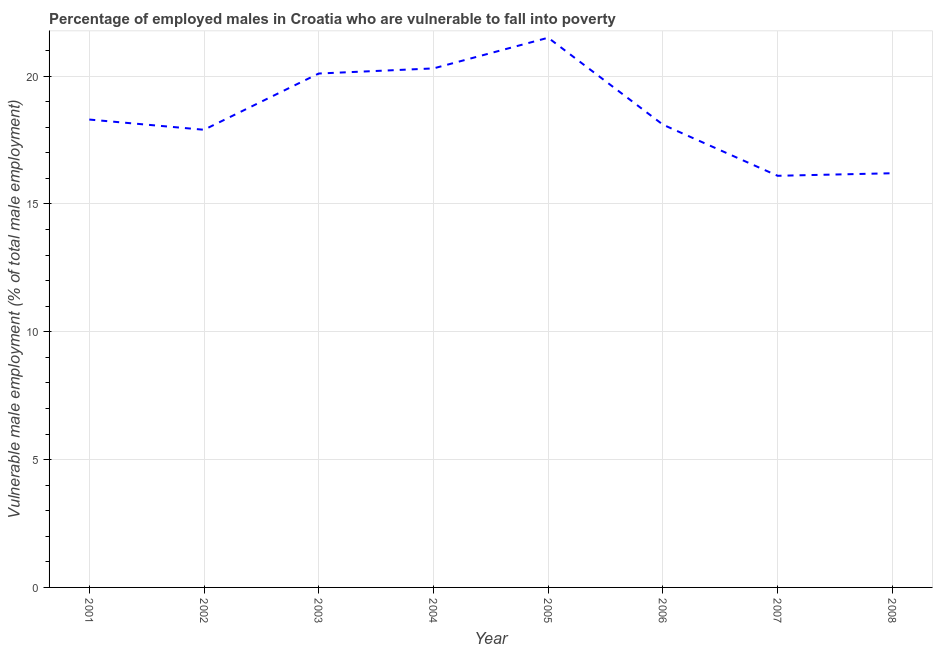What is the percentage of employed males who are vulnerable to fall into poverty in 2005?
Ensure brevity in your answer.  21.5. Across all years, what is the minimum percentage of employed males who are vulnerable to fall into poverty?
Make the answer very short. 16.1. In which year was the percentage of employed males who are vulnerable to fall into poverty maximum?
Make the answer very short. 2005. In which year was the percentage of employed males who are vulnerable to fall into poverty minimum?
Your answer should be very brief. 2007. What is the sum of the percentage of employed males who are vulnerable to fall into poverty?
Ensure brevity in your answer.  148.5. What is the difference between the percentage of employed males who are vulnerable to fall into poverty in 2001 and 2007?
Provide a short and direct response. 2.2. What is the average percentage of employed males who are vulnerable to fall into poverty per year?
Your answer should be very brief. 18.56. What is the median percentage of employed males who are vulnerable to fall into poverty?
Your answer should be compact. 18.2. In how many years, is the percentage of employed males who are vulnerable to fall into poverty greater than 9 %?
Your answer should be compact. 8. What is the ratio of the percentage of employed males who are vulnerable to fall into poverty in 2003 to that in 2007?
Offer a terse response. 1.25. What is the difference between the highest and the second highest percentage of employed males who are vulnerable to fall into poverty?
Keep it short and to the point. 1.2. What is the difference between the highest and the lowest percentage of employed males who are vulnerable to fall into poverty?
Give a very brief answer. 5.4. Does the percentage of employed males who are vulnerable to fall into poverty monotonically increase over the years?
Your answer should be compact. No. How many lines are there?
Offer a very short reply. 1. Are the values on the major ticks of Y-axis written in scientific E-notation?
Your response must be concise. No. Does the graph contain grids?
Offer a terse response. Yes. What is the title of the graph?
Offer a very short reply. Percentage of employed males in Croatia who are vulnerable to fall into poverty. What is the label or title of the X-axis?
Offer a terse response. Year. What is the label or title of the Y-axis?
Keep it short and to the point. Vulnerable male employment (% of total male employment). What is the Vulnerable male employment (% of total male employment) in 2001?
Offer a very short reply. 18.3. What is the Vulnerable male employment (% of total male employment) in 2002?
Your response must be concise. 17.9. What is the Vulnerable male employment (% of total male employment) of 2003?
Provide a short and direct response. 20.1. What is the Vulnerable male employment (% of total male employment) of 2004?
Your answer should be very brief. 20.3. What is the Vulnerable male employment (% of total male employment) in 2006?
Offer a very short reply. 18.1. What is the Vulnerable male employment (% of total male employment) in 2007?
Ensure brevity in your answer.  16.1. What is the Vulnerable male employment (% of total male employment) in 2008?
Provide a succinct answer. 16.2. What is the difference between the Vulnerable male employment (% of total male employment) in 2001 and 2002?
Give a very brief answer. 0.4. What is the difference between the Vulnerable male employment (% of total male employment) in 2001 and 2004?
Give a very brief answer. -2. What is the difference between the Vulnerable male employment (% of total male employment) in 2001 and 2005?
Offer a terse response. -3.2. What is the difference between the Vulnerable male employment (% of total male employment) in 2001 and 2007?
Provide a succinct answer. 2.2. What is the difference between the Vulnerable male employment (% of total male employment) in 2002 and 2005?
Offer a terse response. -3.6. What is the difference between the Vulnerable male employment (% of total male employment) in 2002 and 2007?
Ensure brevity in your answer.  1.8. What is the difference between the Vulnerable male employment (% of total male employment) in 2002 and 2008?
Your answer should be compact. 1.7. What is the difference between the Vulnerable male employment (% of total male employment) in 2003 and 2004?
Offer a very short reply. -0.2. What is the difference between the Vulnerable male employment (% of total male employment) in 2003 and 2006?
Provide a succinct answer. 2. What is the difference between the Vulnerable male employment (% of total male employment) in 2003 and 2008?
Keep it short and to the point. 3.9. What is the difference between the Vulnerable male employment (% of total male employment) in 2004 and 2005?
Your answer should be compact. -1.2. What is the difference between the Vulnerable male employment (% of total male employment) in 2004 and 2007?
Ensure brevity in your answer.  4.2. What is the difference between the Vulnerable male employment (% of total male employment) in 2004 and 2008?
Offer a very short reply. 4.1. What is the difference between the Vulnerable male employment (% of total male employment) in 2005 and 2006?
Offer a very short reply. 3.4. What is the difference between the Vulnerable male employment (% of total male employment) in 2005 and 2007?
Ensure brevity in your answer.  5.4. What is the difference between the Vulnerable male employment (% of total male employment) in 2005 and 2008?
Offer a terse response. 5.3. What is the difference between the Vulnerable male employment (% of total male employment) in 2006 and 2008?
Give a very brief answer. 1.9. What is the difference between the Vulnerable male employment (% of total male employment) in 2007 and 2008?
Your answer should be very brief. -0.1. What is the ratio of the Vulnerable male employment (% of total male employment) in 2001 to that in 2003?
Provide a succinct answer. 0.91. What is the ratio of the Vulnerable male employment (% of total male employment) in 2001 to that in 2004?
Keep it short and to the point. 0.9. What is the ratio of the Vulnerable male employment (% of total male employment) in 2001 to that in 2005?
Provide a short and direct response. 0.85. What is the ratio of the Vulnerable male employment (% of total male employment) in 2001 to that in 2007?
Make the answer very short. 1.14. What is the ratio of the Vulnerable male employment (% of total male employment) in 2001 to that in 2008?
Your response must be concise. 1.13. What is the ratio of the Vulnerable male employment (% of total male employment) in 2002 to that in 2003?
Provide a succinct answer. 0.89. What is the ratio of the Vulnerable male employment (% of total male employment) in 2002 to that in 2004?
Give a very brief answer. 0.88. What is the ratio of the Vulnerable male employment (% of total male employment) in 2002 to that in 2005?
Provide a short and direct response. 0.83. What is the ratio of the Vulnerable male employment (% of total male employment) in 2002 to that in 2007?
Make the answer very short. 1.11. What is the ratio of the Vulnerable male employment (% of total male employment) in 2002 to that in 2008?
Offer a very short reply. 1.1. What is the ratio of the Vulnerable male employment (% of total male employment) in 2003 to that in 2004?
Offer a terse response. 0.99. What is the ratio of the Vulnerable male employment (% of total male employment) in 2003 to that in 2005?
Your answer should be compact. 0.94. What is the ratio of the Vulnerable male employment (% of total male employment) in 2003 to that in 2006?
Give a very brief answer. 1.11. What is the ratio of the Vulnerable male employment (% of total male employment) in 2003 to that in 2007?
Provide a short and direct response. 1.25. What is the ratio of the Vulnerable male employment (% of total male employment) in 2003 to that in 2008?
Ensure brevity in your answer.  1.24. What is the ratio of the Vulnerable male employment (% of total male employment) in 2004 to that in 2005?
Keep it short and to the point. 0.94. What is the ratio of the Vulnerable male employment (% of total male employment) in 2004 to that in 2006?
Your answer should be very brief. 1.12. What is the ratio of the Vulnerable male employment (% of total male employment) in 2004 to that in 2007?
Make the answer very short. 1.26. What is the ratio of the Vulnerable male employment (% of total male employment) in 2004 to that in 2008?
Provide a succinct answer. 1.25. What is the ratio of the Vulnerable male employment (% of total male employment) in 2005 to that in 2006?
Ensure brevity in your answer.  1.19. What is the ratio of the Vulnerable male employment (% of total male employment) in 2005 to that in 2007?
Offer a very short reply. 1.33. What is the ratio of the Vulnerable male employment (% of total male employment) in 2005 to that in 2008?
Provide a succinct answer. 1.33. What is the ratio of the Vulnerable male employment (% of total male employment) in 2006 to that in 2007?
Your answer should be compact. 1.12. What is the ratio of the Vulnerable male employment (% of total male employment) in 2006 to that in 2008?
Give a very brief answer. 1.12. 